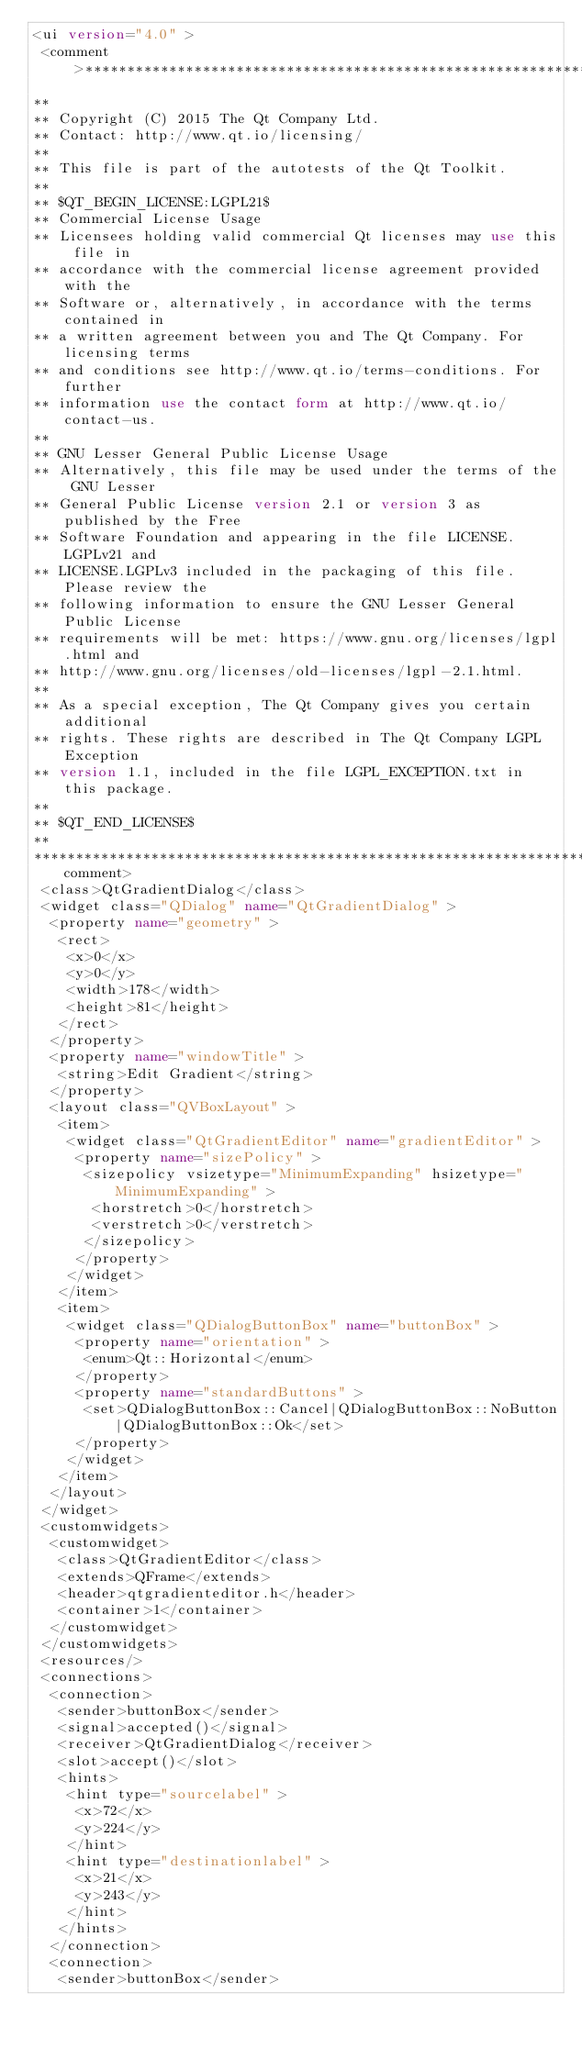<code> <loc_0><loc_0><loc_500><loc_500><_XML_><ui version="4.0" >
 <comment>*********************************************************************
**
** Copyright (C) 2015 The Qt Company Ltd.
** Contact: http://www.qt.io/licensing/
**
** This file is part of the autotests of the Qt Toolkit.
**
** $QT_BEGIN_LICENSE:LGPL21$
** Commercial License Usage
** Licensees holding valid commercial Qt licenses may use this file in
** accordance with the commercial license agreement provided with the
** Software or, alternatively, in accordance with the terms contained in
** a written agreement between you and The Qt Company. For licensing terms
** and conditions see http://www.qt.io/terms-conditions. For further
** information use the contact form at http://www.qt.io/contact-us.
**
** GNU Lesser General Public License Usage
** Alternatively, this file may be used under the terms of the GNU Lesser
** General Public License version 2.1 or version 3 as published by the Free
** Software Foundation and appearing in the file LICENSE.LGPLv21 and
** LICENSE.LGPLv3 included in the packaging of this file. Please review the
** following information to ensure the GNU Lesser General Public License
** requirements will be met: https://www.gnu.org/licenses/lgpl.html and
** http://www.gnu.org/licenses/old-licenses/lgpl-2.1.html.
**
** As a special exception, The Qt Company gives you certain additional
** rights. These rights are described in The Qt Company LGPL Exception
** version 1.1, included in the file LGPL_EXCEPTION.txt in this package.
**
** $QT_END_LICENSE$
**
*********************************************************************</comment>
 <class>QtGradientDialog</class>
 <widget class="QDialog" name="QtGradientDialog" >
  <property name="geometry" >
   <rect>
    <x>0</x>
    <y>0</y>
    <width>178</width>
    <height>81</height>
   </rect>
  </property>
  <property name="windowTitle" >
   <string>Edit Gradient</string>
  </property>
  <layout class="QVBoxLayout" >
   <item>
    <widget class="QtGradientEditor" name="gradientEditor" >
     <property name="sizePolicy" >
      <sizepolicy vsizetype="MinimumExpanding" hsizetype="MinimumExpanding" >
       <horstretch>0</horstretch>
       <verstretch>0</verstretch>
      </sizepolicy>
     </property>
    </widget>
   </item>
   <item>
    <widget class="QDialogButtonBox" name="buttonBox" >
     <property name="orientation" >
      <enum>Qt::Horizontal</enum>
     </property>
     <property name="standardButtons" >
      <set>QDialogButtonBox::Cancel|QDialogButtonBox::NoButton|QDialogButtonBox::Ok</set>
     </property>
    </widget>
   </item>
  </layout>
 </widget>
 <customwidgets>
  <customwidget>
   <class>QtGradientEditor</class>
   <extends>QFrame</extends>
   <header>qtgradienteditor.h</header>
   <container>1</container>
  </customwidget>
 </customwidgets>
 <resources/>
 <connections>
  <connection>
   <sender>buttonBox</sender>
   <signal>accepted()</signal>
   <receiver>QtGradientDialog</receiver>
   <slot>accept()</slot>
   <hints>
    <hint type="sourcelabel" >
     <x>72</x>
     <y>224</y>
    </hint>
    <hint type="destinationlabel" >
     <x>21</x>
     <y>243</y>
    </hint>
   </hints>
  </connection>
  <connection>
   <sender>buttonBox</sender></code> 